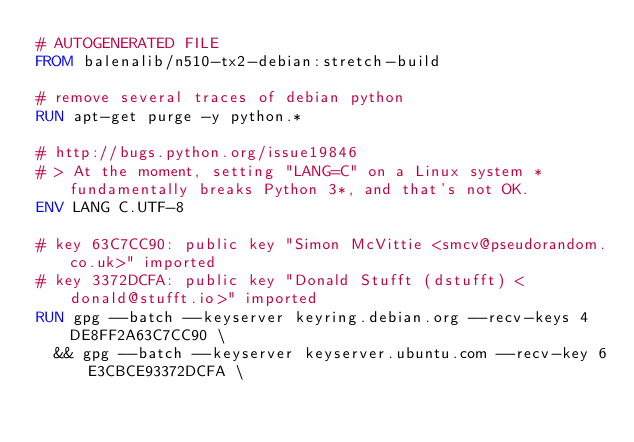<code> <loc_0><loc_0><loc_500><loc_500><_Dockerfile_># AUTOGENERATED FILE
FROM balenalib/n510-tx2-debian:stretch-build

# remove several traces of debian python
RUN apt-get purge -y python.*

# http://bugs.python.org/issue19846
# > At the moment, setting "LANG=C" on a Linux system *fundamentally breaks Python 3*, and that's not OK.
ENV LANG C.UTF-8

# key 63C7CC90: public key "Simon McVittie <smcv@pseudorandom.co.uk>" imported
# key 3372DCFA: public key "Donald Stufft (dstufft) <donald@stufft.io>" imported
RUN gpg --batch --keyserver keyring.debian.org --recv-keys 4DE8FF2A63C7CC90 \
	&& gpg --batch --keyserver keyserver.ubuntu.com --recv-key 6E3CBCE93372DCFA \</code> 